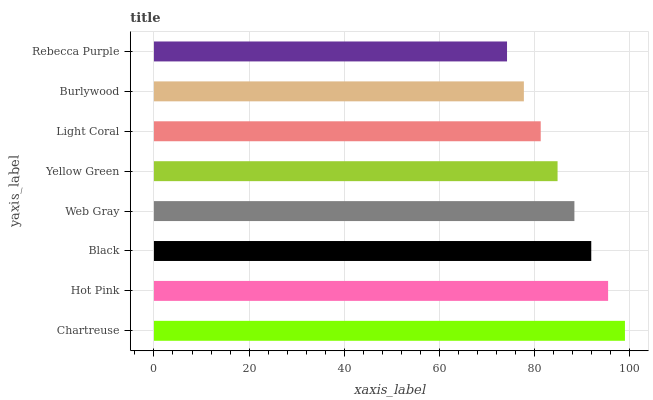Is Rebecca Purple the minimum?
Answer yes or no. Yes. Is Chartreuse the maximum?
Answer yes or no. Yes. Is Hot Pink the minimum?
Answer yes or no. No. Is Hot Pink the maximum?
Answer yes or no. No. Is Chartreuse greater than Hot Pink?
Answer yes or no. Yes. Is Hot Pink less than Chartreuse?
Answer yes or no. Yes. Is Hot Pink greater than Chartreuse?
Answer yes or no. No. Is Chartreuse less than Hot Pink?
Answer yes or no. No. Is Web Gray the high median?
Answer yes or no. Yes. Is Yellow Green the low median?
Answer yes or no. Yes. Is Black the high median?
Answer yes or no. No. Is Web Gray the low median?
Answer yes or no. No. 